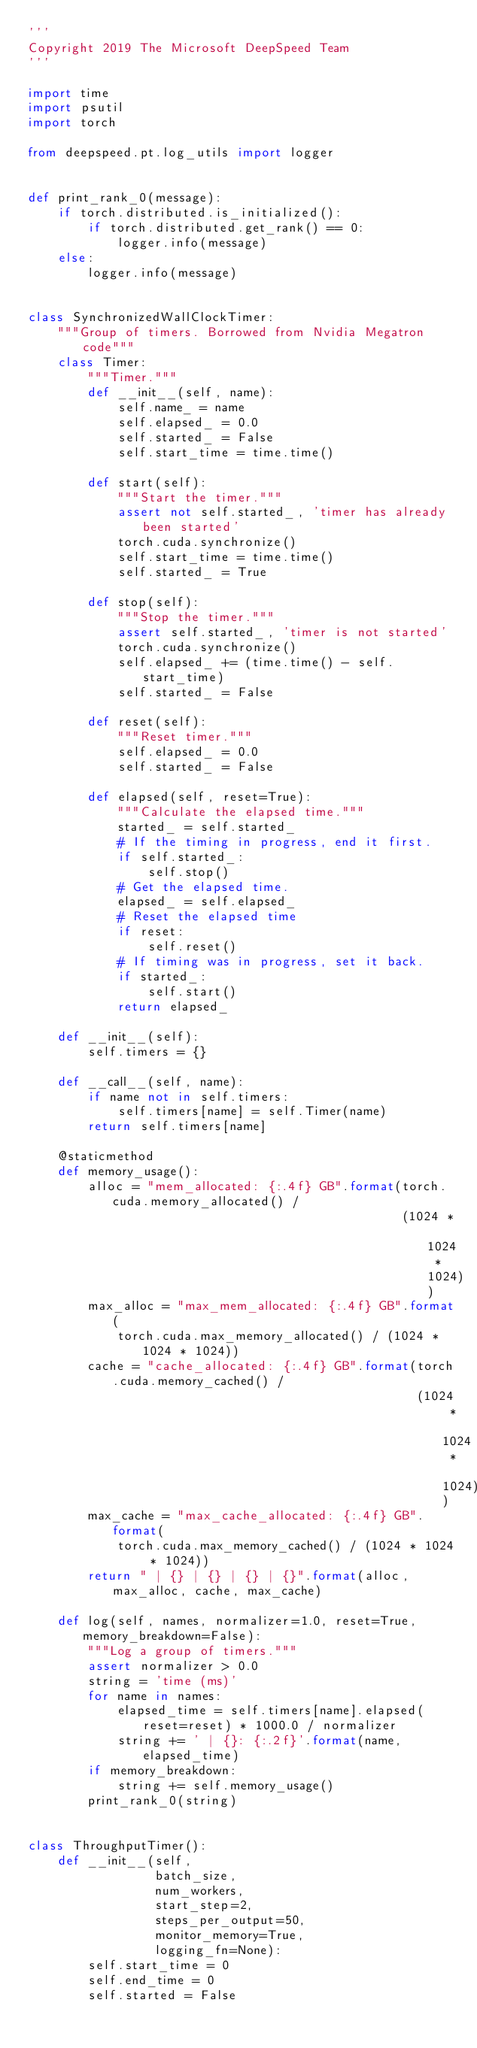<code> <loc_0><loc_0><loc_500><loc_500><_Python_>'''
Copyright 2019 The Microsoft DeepSpeed Team
'''

import time
import psutil
import torch

from deepspeed.pt.log_utils import logger


def print_rank_0(message):
    if torch.distributed.is_initialized():
        if torch.distributed.get_rank() == 0:
            logger.info(message)
    else:
        logger.info(message)


class SynchronizedWallClockTimer:
    """Group of timers. Borrowed from Nvidia Megatron code"""
    class Timer:
        """Timer."""
        def __init__(self, name):
            self.name_ = name
            self.elapsed_ = 0.0
            self.started_ = False
            self.start_time = time.time()

        def start(self):
            """Start the timer."""
            assert not self.started_, 'timer has already been started'
            torch.cuda.synchronize()
            self.start_time = time.time()
            self.started_ = True

        def stop(self):
            """Stop the timer."""
            assert self.started_, 'timer is not started'
            torch.cuda.synchronize()
            self.elapsed_ += (time.time() - self.start_time)
            self.started_ = False

        def reset(self):
            """Reset timer."""
            self.elapsed_ = 0.0
            self.started_ = False

        def elapsed(self, reset=True):
            """Calculate the elapsed time."""
            started_ = self.started_
            # If the timing in progress, end it first.
            if self.started_:
                self.stop()
            # Get the elapsed time.
            elapsed_ = self.elapsed_
            # Reset the elapsed time
            if reset:
                self.reset()
            # If timing was in progress, set it back.
            if started_:
                self.start()
            return elapsed_

    def __init__(self):
        self.timers = {}

    def __call__(self, name):
        if name not in self.timers:
            self.timers[name] = self.Timer(name)
        return self.timers[name]

    @staticmethod
    def memory_usage():
        alloc = "mem_allocated: {:.4f} GB".format(torch.cuda.memory_allocated() /
                                                  (1024 * 1024 * 1024))
        max_alloc = "max_mem_allocated: {:.4f} GB".format(
            torch.cuda.max_memory_allocated() / (1024 * 1024 * 1024))
        cache = "cache_allocated: {:.4f} GB".format(torch.cuda.memory_cached() /
                                                    (1024 * 1024 * 1024))
        max_cache = "max_cache_allocated: {:.4f} GB".format(
            torch.cuda.max_memory_cached() / (1024 * 1024 * 1024))
        return " | {} | {} | {} | {}".format(alloc, max_alloc, cache, max_cache)

    def log(self, names, normalizer=1.0, reset=True, memory_breakdown=False):
        """Log a group of timers."""
        assert normalizer > 0.0
        string = 'time (ms)'
        for name in names:
            elapsed_time = self.timers[name].elapsed(reset=reset) * 1000.0 / normalizer
            string += ' | {}: {:.2f}'.format(name, elapsed_time)
        if memory_breakdown:
            string += self.memory_usage()
        print_rank_0(string)


class ThroughputTimer():
    def __init__(self,
                 batch_size,
                 num_workers,
                 start_step=2,
                 steps_per_output=50,
                 monitor_memory=True,
                 logging_fn=None):
        self.start_time = 0
        self.end_time = 0
        self.started = False</code> 